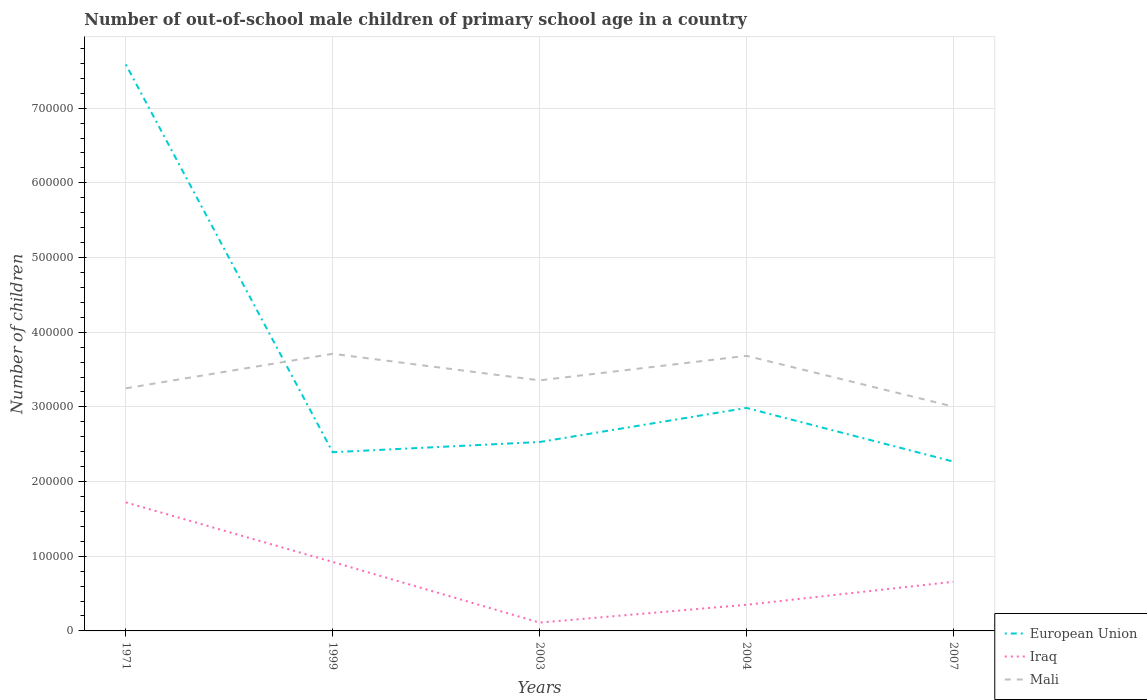How many different coloured lines are there?
Keep it short and to the point. 3. Is the number of lines equal to the number of legend labels?
Make the answer very short. Yes. Across all years, what is the maximum number of out-of-school male children in Iraq?
Keep it short and to the point. 1.11e+04. What is the total number of out-of-school male children in European Union in the graph?
Your response must be concise. -5.93e+04. What is the difference between the highest and the second highest number of out-of-school male children in European Union?
Your answer should be compact. 5.32e+05. Is the number of out-of-school male children in Mali strictly greater than the number of out-of-school male children in European Union over the years?
Your answer should be very brief. No. How many lines are there?
Give a very brief answer. 3. What is the difference between two consecutive major ticks on the Y-axis?
Offer a very short reply. 1.00e+05. Are the values on the major ticks of Y-axis written in scientific E-notation?
Your answer should be very brief. No. Does the graph contain any zero values?
Offer a terse response. No. How many legend labels are there?
Your response must be concise. 3. How are the legend labels stacked?
Provide a short and direct response. Vertical. What is the title of the graph?
Give a very brief answer. Number of out-of-school male children of primary school age in a country. What is the label or title of the Y-axis?
Offer a very short reply. Number of children. What is the Number of children of European Union in 1971?
Your response must be concise. 7.58e+05. What is the Number of children of Iraq in 1971?
Make the answer very short. 1.72e+05. What is the Number of children of Mali in 1971?
Provide a succinct answer. 3.25e+05. What is the Number of children of European Union in 1999?
Your answer should be very brief. 2.39e+05. What is the Number of children in Iraq in 1999?
Your answer should be very brief. 9.23e+04. What is the Number of children of Mali in 1999?
Ensure brevity in your answer.  3.71e+05. What is the Number of children in European Union in 2003?
Your answer should be very brief. 2.53e+05. What is the Number of children in Iraq in 2003?
Give a very brief answer. 1.11e+04. What is the Number of children in Mali in 2003?
Ensure brevity in your answer.  3.36e+05. What is the Number of children of European Union in 2004?
Provide a short and direct response. 2.99e+05. What is the Number of children in Iraq in 2004?
Give a very brief answer. 3.50e+04. What is the Number of children of Mali in 2004?
Ensure brevity in your answer.  3.68e+05. What is the Number of children in European Union in 2007?
Offer a terse response. 2.27e+05. What is the Number of children in Iraq in 2007?
Your response must be concise. 6.58e+04. What is the Number of children of Mali in 2007?
Provide a succinct answer. 3.00e+05. Across all years, what is the maximum Number of children in European Union?
Provide a short and direct response. 7.58e+05. Across all years, what is the maximum Number of children of Iraq?
Offer a terse response. 1.72e+05. Across all years, what is the maximum Number of children in Mali?
Make the answer very short. 3.71e+05. Across all years, what is the minimum Number of children in European Union?
Make the answer very short. 2.27e+05. Across all years, what is the minimum Number of children in Iraq?
Keep it short and to the point. 1.11e+04. Across all years, what is the minimum Number of children in Mali?
Offer a terse response. 3.00e+05. What is the total Number of children in European Union in the graph?
Keep it short and to the point. 1.78e+06. What is the total Number of children in Iraq in the graph?
Your response must be concise. 3.76e+05. What is the total Number of children in Mali in the graph?
Offer a terse response. 1.70e+06. What is the difference between the Number of children in European Union in 1971 and that in 1999?
Give a very brief answer. 5.19e+05. What is the difference between the Number of children in Iraq in 1971 and that in 1999?
Make the answer very short. 7.98e+04. What is the difference between the Number of children in Mali in 1971 and that in 1999?
Your response must be concise. -4.62e+04. What is the difference between the Number of children in European Union in 1971 and that in 2003?
Your answer should be compact. 5.06e+05. What is the difference between the Number of children of Iraq in 1971 and that in 2003?
Offer a very short reply. 1.61e+05. What is the difference between the Number of children of Mali in 1971 and that in 2003?
Your response must be concise. -1.06e+04. What is the difference between the Number of children of European Union in 1971 and that in 2004?
Offer a very short reply. 4.60e+05. What is the difference between the Number of children of Iraq in 1971 and that in 2004?
Keep it short and to the point. 1.37e+05. What is the difference between the Number of children of Mali in 1971 and that in 2004?
Give a very brief answer. -4.35e+04. What is the difference between the Number of children of European Union in 1971 and that in 2007?
Provide a short and direct response. 5.32e+05. What is the difference between the Number of children of Iraq in 1971 and that in 2007?
Keep it short and to the point. 1.06e+05. What is the difference between the Number of children in Mali in 1971 and that in 2007?
Offer a terse response. 2.45e+04. What is the difference between the Number of children of European Union in 1999 and that in 2003?
Ensure brevity in your answer.  -1.37e+04. What is the difference between the Number of children of Iraq in 1999 and that in 2003?
Provide a short and direct response. 8.12e+04. What is the difference between the Number of children in Mali in 1999 and that in 2003?
Your answer should be very brief. 3.56e+04. What is the difference between the Number of children of European Union in 1999 and that in 2004?
Your answer should be compact. -5.93e+04. What is the difference between the Number of children in Iraq in 1999 and that in 2004?
Ensure brevity in your answer.  5.73e+04. What is the difference between the Number of children of Mali in 1999 and that in 2004?
Keep it short and to the point. 2702. What is the difference between the Number of children of European Union in 1999 and that in 2007?
Provide a short and direct response. 1.26e+04. What is the difference between the Number of children of Iraq in 1999 and that in 2007?
Make the answer very short. 2.65e+04. What is the difference between the Number of children of Mali in 1999 and that in 2007?
Provide a succinct answer. 7.07e+04. What is the difference between the Number of children in European Union in 2003 and that in 2004?
Your answer should be very brief. -4.56e+04. What is the difference between the Number of children of Iraq in 2003 and that in 2004?
Offer a very short reply. -2.39e+04. What is the difference between the Number of children in Mali in 2003 and that in 2004?
Give a very brief answer. -3.29e+04. What is the difference between the Number of children in European Union in 2003 and that in 2007?
Keep it short and to the point. 2.62e+04. What is the difference between the Number of children in Iraq in 2003 and that in 2007?
Give a very brief answer. -5.47e+04. What is the difference between the Number of children of Mali in 2003 and that in 2007?
Keep it short and to the point. 3.52e+04. What is the difference between the Number of children in European Union in 2004 and that in 2007?
Give a very brief answer. 7.18e+04. What is the difference between the Number of children of Iraq in 2004 and that in 2007?
Keep it short and to the point. -3.08e+04. What is the difference between the Number of children in Mali in 2004 and that in 2007?
Your response must be concise. 6.80e+04. What is the difference between the Number of children of European Union in 1971 and the Number of children of Iraq in 1999?
Your response must be concise. 6.66e+05. What is the difference between the Number of children in European Union in 1971 and the Number of children in Mali in 1999?
Ensure brevity in your answer.  3.87e+05. What is the difference between the Number of children in Iraq in 1971 and the Number of children in Mali in 1999?
Offer a very short reply. -1.99e+05. What is the difference between the Number of children in European Union in 1971 and the Number of children in Iraq in 2003?
Provide a short and direct response. 7.47e+05. What is the difference between the Number of children of European Union in 1971 and the Number of children of Mali in 2003?
Keep it short and to the point. 4.23e+05. What is the difference between the Number of children in Iraq in 1971 and the Number of children in Mali in 2003?
Your answer should be compact. -1.63e+05. What is the difference between the Number of children of European Union in 1971 and the Number of children of Iraq in 2004?
Provide a short and direct response. 7.23e+05. What is the difference between the Number of children of European Union in 1971 and the Number of children of Mali in 2004?
Provide a succinct answer. 3.90e+05. What is the difference between the Number of children in Iraq in 1971 and the Number of children in Mali in 2004?
Give a very brief answer. -1.96e+05. What is the difference between the Number of children of European Union in 1971 and the Number of children of Iraq in 2007?
Ensure brevity in your answer.  6.93e+05. What is the difference between the Number of children of European Union in 1971 and the Number of children of Mali in 2007?
Provide a short and direct response. 4.58e+05. What is the difference between the Number of children in Iraq in 1971 and the Number of children in Mali in 2007?
Ensure brevity in your answer.  -1.28e+05. What is the difference between the Number of children in European Union in 1999 and the Number of children in Iraq in 2003?
Your answer should be very brief. 2.28e+05. What is the difference between the Number of children in European Union in 1999 and the Number of children in Mali in 2003?
Keep it short and to the point. -9.62e+04. What is the difference between the Number of children of Iraq in 1999 and the Number of children of Mali in 2003?
Offer a very short reply. -2.43e+05. What is the difference between the Number of children of European Union in 1999 and the Number of children of Iraq in 2004?
Make the answer very short. 2.04e+05. What is the difference between the Number of children of European Union in 1999 and the Number of children of Mali in 2004?
Your answer should be very brief. -1.29e+05. What is the difference between the Number of children of Iraq in 1999 and the Number of children of Mali in 2004?
Provide a short and direct response. -2.76e+05. What is the difference between the Number of children of European Union in 1999 and the Number of children of Iraq in 2007?
Make the answer very short. 1.73e+05. What is the difference between the Number of children in European Union in 1999 and the Number of children in Mali in 2007?
Offer a terse response. -6.10e+04. What is the difference between the Number of children of Iraq in 1999 and the Number of children of Mali in 2007?
Give a very brief answer. -2.08e+05. What is the difference between the Number of children of European Union in 2003 and the Number of children of Iraq in 2004?
Make the answer very short. 2.18e+05. What is the difference between the Number of children in European Union in 2003 and the Number of children in Mali in 2004?
Make the answer very short. -1.15e+05. What is the difference between the Number of children in Iraq in 2003 and the Number of children in Mali in 2004?
Provide a short and direct response. -3.57e+05. What is the difference between the Number of children in European Union in 2003 and the Number of children in Iraq in 2007?
Offer a terse response. 1.87e+05. What is the difference between the Number of children of European Union in 2003 and the Number of children of Mali in 2007?
Provide a succinct answer. -4.74e+04. What is the difference between the Number of children in Iraq in 2003 and the Number of children in Mali in 2007?
Your answer should be very brief. -2.89e+05. What is the difference between the Number of children in European Union in 2004 and the Number of children in Iraq in 2007?
Provide a short and direct response. 2.33e+05. What is the difference between the Number of children of European Union in 2004 and the Number of children of Mali in 2007?
Give a very brief answer. -1764. What is the difference between the Number of children of Iraq in 2004 and the Number of children of Mali in 2007?
Make the answer very short. -2.65e+05. What is the average Number of children of European Union per year?
Your response must be concise. 3.55e+05. What is the average Number of children of Iraq per year?
Your answer should be compact. 7.53e+04. What is the average Number of children in Mali per year?
Your answer should be very brief. 3.40e+05. In the year 1971, what is the difference between the Number of children in European Union and Number of children in Iraq?
Keep it short and to the point. 5.86e+05. In the year 1971, what is the difference between the Number of children in European Union and Number of children in Mali?
Give a very brief answer. 4.34e+05. In the year 1971, what is the difference between the Number of children of Iraq and Number of children of Mali?
Give a very brief answer. -1.53e+05. In the year 1999, what is the difference between the Number of children in European Union and Number of children in Iraq?
Ensure brevity in your answer.  1.47e+05. In the year 1999, what is the difference between the Number of children of European Union and Number of children of Mali?
Your response must be concise. -1.32e+05. In the year 1999, what is the difference between the Number of children in Iraq and Number of children in Mali?
Offer a terse response. -2.79e+05. In the year 2003, what is the difference between the Number of children of European Union and Number of children of Iraq?
Your answer should be very brief. 2.42e+05. In the year 2003, what is the difference between the Number of children of European Union and Number of children of Mali?
Your answer should be compact. -8.25e+04. In the year 2003, what is the difference between the Number of children in Iraq and Number of children in Mali?
Offer a very short reply. -3.24e+05. In the year 2004, what is the difference between the Number of children in European Union and Number of children in Iraq?
Offer a terse response. 2.64e+05. In the year 2004, what is the difference between the Number of children in European Union and Number of children in Mali?
Ensure brevity in your answer.  -6.98e+04. In the year 2004, what is the difference between the Number of children of Iraq and Number of children of Mali?
Offer a terse response. -3.33e+05. In the year 2007, what is the difference between the Number of children of European Union and Number of children of Iraq?
Offer a very short reply. 1.61e+05. In the year 2007, what is the difference between the Number of children in European Union and Number of children in Mali?
Provide a succinct answer. -7.36e+04. In the year 2007, what is the difference between the Number of children of Iraq and Number of children of Mali?
Your response must be concise. -2.35e+05. What is the ratio of the Number of children in European Union in 1971 to that in 1999?
Make the answer very short. 3.17. What is the ratio of the Number of children in Iraq in 1971 to that in 1999?
Make the answer very short. 1.86. What is the ratio of the Number of children of Mali in 1971 to that in 1999?
Provide a succinct answer. 0.88. What is the ratio of the Number of children of European Union in 1971 to that in 2003?
Your answer should be compact. 3. What is the ratio of the Number of children in Iraq in 1971 to that in 2003?
Your answer should be compact. 15.46. What is the ratio of the Number of children of Mali in 1971 to that in 2003?
Provide a short and direct response. 0.97. What is the ratio of the Number of children in European Union in 1971 to that in 2004?
Provide a short and direct response. 2.54. What is the ratio of the Number of children in Iraq in 1971 to that in 2004?
Provide a short and direct response. 4.91. What is the ratio of the Number of children of Mali in 1971 to that in 2004?
Your response must be concise. 0.88. What is the ratio of the Number of children of European Union in 1971 to that in 2007?
Your answer should be very brief. 3.35. What is the ratio of the Number of children of Iraq in 1971 to that in 2007?
Provide a succinct answer. 2.61. What is the ratio of the Number of children of Mali in 1971 to that in 2007?
Your answer should be compact. 1.08. What is the ratio of the Number of children in European Union in 1999 to that in 2003?
Your response must be concise. 0.95. What is the ratio of the Number of children in Iraq in 1999 to that in 2003?
Keep it short and to the point. 8.29. What is the ratio of the Number of children in Mali in 1999 to that in 2003?
Offer a terse response. 1.11. What is the ratio of the Number of children in European Union in 1999 to that in 2004?
Ensure brevity in your answer.  0.8. What is the ratio of the Number of children in Iraq in 1999 to that in 2004?
Keep it short and to the point. 2.64. What is the ratio of the Number of children of Mali in 1999 to that in 2004?
Your answer should be compact. 1.01. What is the ratio of the Number of children of European Union in 1999 to that in 2007?
Provide a short and direct response. 1.06. What is the ratio of the Number of children in Iraq in 1999 to that in 2007?
Give a very brief answer. 1.4. What is the ratio of the Number of children in Mali in 1999 to that in 2007?
Keep it short and to the point. 1.24. What is the ratio of the Number of children of European Union in 2003 to that in 2004?
Your response must be concise. 0.85. What is the ratio of the Number of children in Iraq in 2003 to that in 2004?
Offer a very short reply. 0.32. What is the ratio of the Number of children in Mali in 2003 to that in 2004?
Your response must be concise. 0.91. What is the ratio of the Number of children in European Union in 2003 to that in 2007?
Make the answer very short. 1.12. What is the ratio of the Number of children of Iraq in 2003 to that in 2007?
Offer a very short reply. 0.17. What is the ratio of the Number of children in Mali in 2003 to that in 2007?
Your answer should be very brief. 1.12. What is the ratio of the Number of children in European Union in 2004 to that in 2007?
Your response must be concise. 1.32. What is the ratio of the Number of children in Iraq in 2004 to that in 2007?
Ensure brevity in your answer.  0.53. What is the ratio of the Number of children of Mali in 2004 to that in 2007?
Keep it short and to the point. 1.23. What is the difference between the highest and the second highest Number of children of European Union?
Offer a very short reply. 4.60e+05. What is the difference between the highest and the second highest Number of children of Iraq?
Make the answer very short. 7.98e+04. What is the difference between the highest and the second highest Number of children in Mali?
Offer a terse response. 2702. What is the difference between the highest and the lowest Number of children in European Union?
Provide a short and direct response. 5.32e+05. What is the difference between the highest and the lowest Number of children of Iraq?
Your answer should be very brief. 1.61e+05. What is the difference between the highest and the lowest Number of children of Mali?
Your response must be concise. 7.07e+04. 